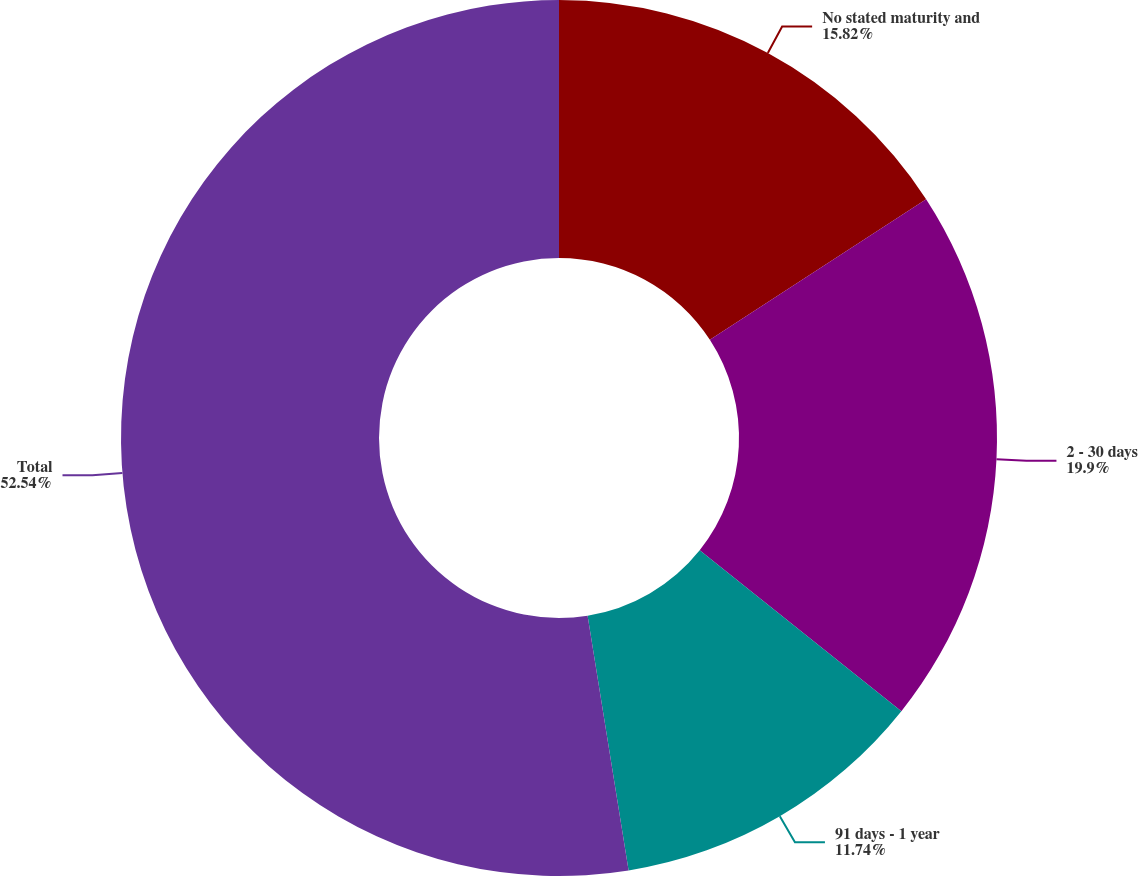Convert chart to OTSL. <chart><loc_0><loc_0><loc_500><loc_500><pie_chart><fcel>No stated maturity and<fcel>2 - 30 days<fcel>91 days - 1 year<fcel>Total<nl><fcel>15.82%<fcel>19.9%<fcel>11.74%<fcel>52.54%<nl></chart> 